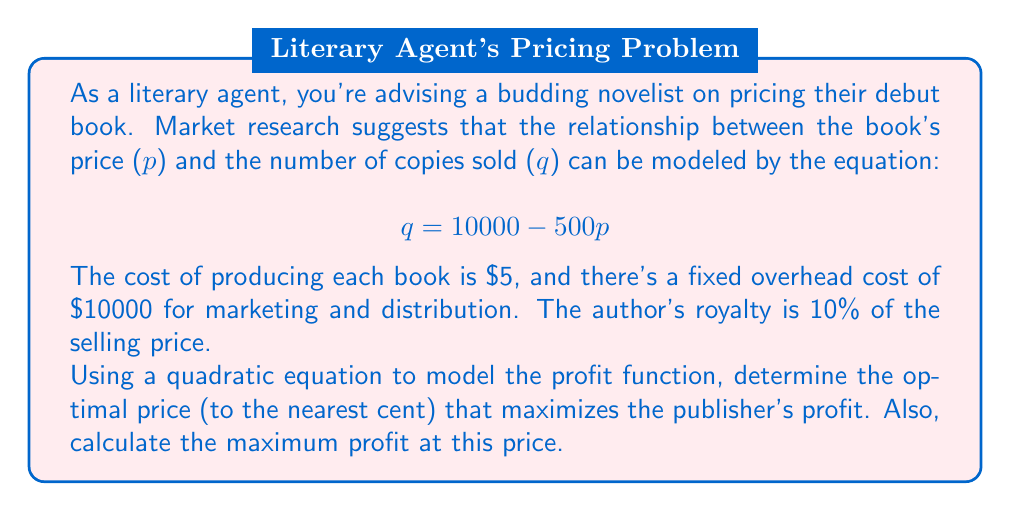Provide a solution to this math problem. Let's approach this step-by-step:

1) First, we need to formulate the profit function. Profit is revenue minus costs.

2) Revenue is price times quantity: $R = pq = p(10000 - 500p) = 10000p - 500p^2$

3) Costs include:
   - Production cost: $5q = 5(10000 - 500p) = 50000 - 2500p$
   - Fixed overhead: $10000$
   - Author's royalty: $0.1pq = 0.1p(10000 - 500p) = 1000p - 50p^2$

4) Total cost: $C = (50000 - 2500p) + 10000 + (1000p - 50p^2) = 60000 - 1500p - 50p^2$

5) Profit function: 
   $$P = R - C = (10000p - 500p^2) - (60000 - 1500p - 50p^2)$$
   $$P = -450p^2 + 11500p - 60000$$

6) To find the maximum profit, we differentiate P with respect to p and set it to zero:
   $$\frac{dP}{dp} = -900p + 11500 = 0$$

7) Solving this:
   $$-900p = -11500$$
   $$p = \frac{11500}{900} = 12.7777...$$

8) The second derivative is negative (-900), confirming this is a maximum.

9) Rounding to the nearest cent: $p = $12.78

10) To find the maximum profit, we substitute this price back into our profit function:
    $$P = -450(12.78)^2 + 11500(12.78) - 60000 = 13,605.62$$
Answer: The optimal price is $12.78, and the maximum profit at this price is $13,605.62. 